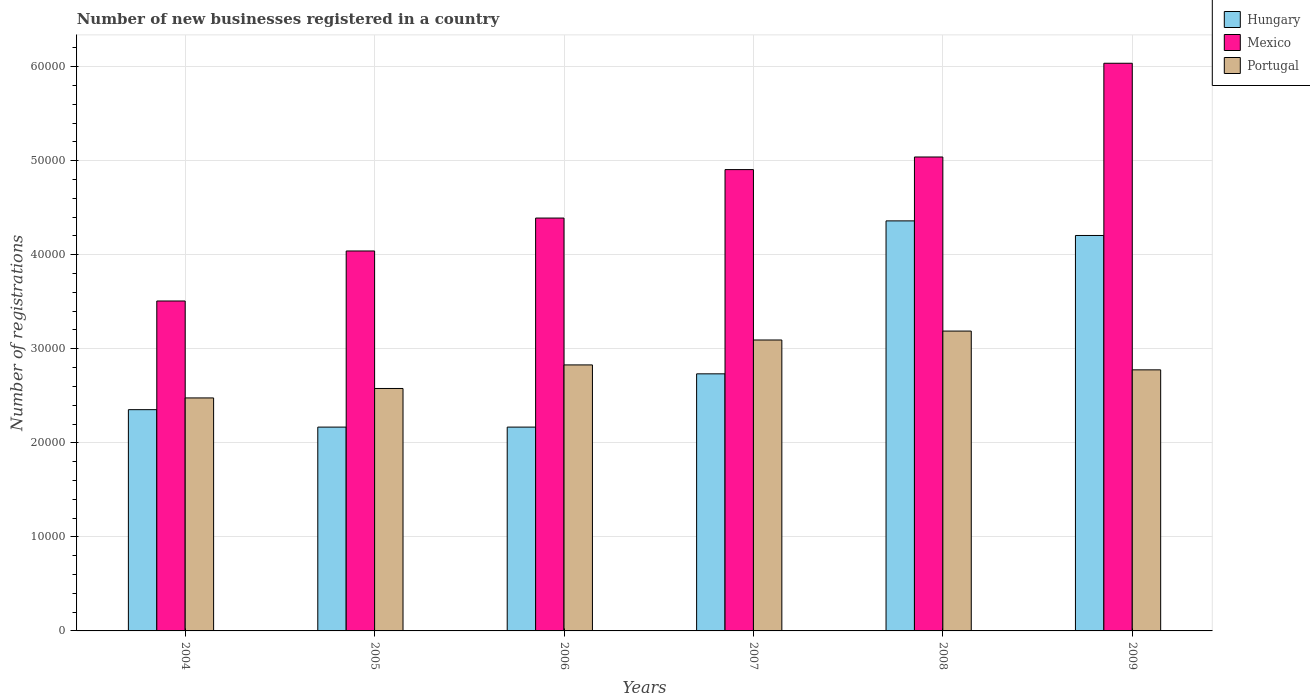How many different coloured bars are there?
Your answer should be very brief. 3. How many groups of bars are there?
Offer a very short reply. 6. How many bars are there on the 4th tick from the left?
Give a very brief answer. 3. How many bars are there on the 2nd tick from the right?
Ensure brevity in your answer.  3. What is the label of the 5th group of bars from the left?
Your answer should be compact. 2008. What is the number of new businesses registered in Mexico in 2005?
Your answer should be very brief. 4.04e+04. Across all years, what is the maximum number of new businesses registered in Mexico?
Your answer should be compact. 6.04e+04. Across all years, what is the minimum number of new businesses registered in Mexico?
Ensure brevity in your answer.  3.51e+04. In which year was the number of new businesses registered in Portugal maximum?
Keep it short and to the point. 2008. In which year was the number of new businesses registered in Hungary minimum?
Ensure brevity in your answer.  2005. What is the total number of new businesses registered in Portugal in the graph?
Offer a very short reply. 1.69e+05. What is the difference between the number of new businesses registered in Portugal in 2007 and that in 2009?
Provide a short and direct response. 3175. What is the difference between the number of new businesses registered in Portugal in 2007 and the number of new businesses registered in Hungary in 2005?
Your answer should be compact. 9262. What is the average number of new businesses registered in Portugal per year?
Give a very brief answer. 2.82e+04. In the year 2008, what is the difference between the number of new businesses registered in Portugal and number of new businesses registered in Hungary?
Provide a short and direct response. -1.17e+04. What is the ratio of the number of new businesses registered in Portugal in 2005 to that in 2007?
Your response must be concise. 0.83. What is the difference between the highest and the second highest number of new businesses registered in Hungary?
Provide a succinct answer. 1552. What is the difference between the highest and the lowest number of new businesses registered in Portugal?
Give a very brief answer. 7109. In how many years, is the number of new businesses registered in Mexico greater than the average number of new businesses registered in Mexico taken over all years?
Give a very brief answer. 3. What does the 2nd bar from the left in 2005 represents?
Your answer should be compact. Mexico. Is it the case that in every year, the sum of the number of new businesses registered in Mexico and number of new businesses registered in Hungary is greater than the number of new businesses registered in Portugal?
Keep it short and to the point. Yes. How many years are there in the graph?
Provide a succinct answer. 6. Are the values on the major ticks of Y-axis written in scientific E-notation?
Ensure brevity in your answer.  No. Where does the legend appear in the graph?
Keep it short and to the point. Top right. What is the title of the graph?
Offer a very short reply. Number of new businesses registered in a country. What is the label or title of the X-axis?
Make the answer very short. Years. What is the label or title of the Y-axis?
Make the answer very short. Number of registrations. What is the Number of registrations in Hungary in 2004?
Provide a succinct answer. 2.35e+04. What is the Number of registrations in Mexico in 2004?
Offer a terse response. 3.51e+04. What is the Number of registrations of Portugal in 2004?
Your answer should be very brief. 2.48e+04. What is the Number of registrations in Hungary in 2005?
Give a very brief answer. 2.17e+04. What is the Number of registrations of Mexico in 2005?
Keep it short and to the point. 4.04e+04. What is the Number of registrations in Portugal in 2005?
Ensure brevity in your answer.  2.58e+04. What is the Number of registrations in Hungary in 2006?
Provide a short and direct response. 2.17e+04. What is the Number of registrations of Mexico in 2006?
Offer a terse response. 4.39e+04. What is the Number of registrations of Portugal in 2006?
Your answer should be very brief. 2.83e+04. What is the Number of registrations in Hungary in 2007?
Offer a very short reply. 2.73e+04. What is the Number of registrations of Mexico in 2007?
Provide a succinct answer. 4.90e+04. What is the Number of registrations in Portugal in 2007?
Keep it short and to the point. 3.09e+04. What is the Number of registrations in Hungary in 2008?
Offer a very short reply. 4.36e+04. What is the Number of registrations of Mexico in 2008?
Your answer should be compact. 5.04e+04. What is the Number of registrations of Portugal in 2008?
Provide a succinct answer. 3.19e+04. What is the Number of registrations of Hungary in 2009?
Provide a short and direct response. 4.20e+04. What is the Number of registrations in Mexico in 2009?
Your answer should be compact. 6.04e+04. What is the Number of registrations of Portugal in 2009?
Offer a very short reply. 2.78e+04. Across all years, what is the maximum Number of registrations of Hungary?
Offer a terse response. 4.36e+04. Across all years, what is the maximum Number of registrations of Mexico?
Provide a short and direct response. 6.04e+04. Across all years, what is the maximum Number of registrations of Portugal?
Offer a terse response. 3.19e+04. Across all years, what is the minimum Number of registrations of Hungary?
Your answer should be very brief. 2.17e+04. Across all years, what is the minimum Number of registrations of Mexico?
Make the answer very short. 3.51e+04. Across all years, what is the minimum Number of registrations in Portugal?
Your answer should be very brief. 2.48e+04. What is the total Number of registrations of Hungary in the graph?
Offer a terse response. 1.80e+05. What is the total Number of registrations in Mexico in the graph?
Keep it short and to the point. 2.79e+05. What is the total Number of registrations in Portugal in the graph?
Keep it short and to the point. 1.69e+05. What is the difference between the Number of registrations of Hungary in 2004 and that in 2005?
Offer a very short reply. 1854. What is the difference between the Number of registrations of Mexico in 2004 and that in 2005?
Offer a terse response. -5317. What is the difference between the Number of registrations of Portugal in 2004 and that in 2005?
Offer a very short reply. -1005. What is the difference between the Number of registrations in Hungary in 2004 and that in 2006?
Provide a short and direct response. 1854. What is the difference between the Number of registrations in Mexico in 2004 and that in 2006?
Offer a terse response. -8818. What is the difference between the Number of registrations in Portugal in 2004 and that in 2006?
Your answer should be compact. -3510. What is the difference between the Number of registrations in Hungary in 2004 and that in 2007?
Provide a short and direct response. -3809. What is the difference between the Number of registrations of Mexico in 2004 and that in 2007?
Ensure brevity in your answer.  -1.40e+04. What is the difference between the Number of registrations of Portugal in 2004 and that in 2007?
Provide a short and direct response. -6160. What is the difference between the Number of registrations in Hungary in 2004 and that in 2008?
Offer a terse response. -2.01e+04. What is the difference between the Number of registrations of Mexico in 2004 and that in 2008?
Keep it short and to the point. -1.53e+04. What is the difference between the Number of registrations in Portugal in 2004 and that in 2008?
Provide a succinct answer. -7109. What is the difference between the Number of registrations of Hungary in 2004 and that in 2009?
Make the answer very short. -1.85e+04. What is the difference between the Number of registrations of Mexico in 2004 and that in 2009?
Provide a short and direct response. -2.53e+04. What is the difference between the Number of registrations of Portugal in 2004 and that in 2009?
Provide a succinct answer. -2985. What is the difference between the Number of registrations of Hungary in 2005 and that in 2006?
Provide a succinct answer. 0. What is the difference between the Number of registrations in Mexico in 2005 and that in 2006?
Provide a succinct answer. -3501. What is the difference between the Number of registrations of Portugal in 2005 and that in 2006?
Offer a terse response. -2505. What is the difference between the Number of registrations in Hungary in 2005 and that in 2007?
Provide a short and direct response. -5663. What is the difference between the Number of registrations of Mexico in 2005 and that in 2007?
Your answer should be very brief. -8652. What is the difference between the Number of registrations of Portugal in 2005 and that in 2007?
Give a very brief answer. -5155. What is the difference between the Number of registrations in Hungary in 2005 and that in 2008?
Your answer should be compact. -2.19e+04. What is the difference between the Number of registrations in Mexico in 2005 and that in 2008?
Give a very brief answer. -9994. What is the difference between the Number of registrations of Portugal in 2005 and that in 2008?
Keep it short and to the point. -6104. What is the difference between the Number of registrations in Hungary in 2005 and that in 2009?
Make the answer very short. -2.04e+04. What is the difference between the Number of registrations of Mexico in 2005 and that in 2009?
Your response must be concise. -2.00e+04. What is the difference between the Number of registrations of Portugal in 2005 and that in 2009?
Provide a succinct answer. -1980. What is the difference between the Number of registrations in Hungary in 2006 and that in 2007?
Your answer should be very brief. -5663. What is the difference between the Number of registrations of Mexico in 2006 and that in 2007?
Make the answer very short. -5151. What is the difference between the Number of registrations of Portugal in 2006 and that in 2007?
Your answer should be compact. -2650. What is the difference between the Number of registrations in Hungary in 2006 and that in 2008?
Ensure brevity in your answer.  -2.19e+04. What is the difference between the Number of registrations in Mexico in 2006 and that in 2008?
Provide a short and direct response. -6493. What is the difference between the Number of registrations in Portugal in 2006 and that in 2008?
Give a very brief answer. -3599. What is the difference between the Number of registrations of Hungary in 2006 and that in 2009?
Your answer should be very brief. -2.04e+04. What is the difference between the Number of registrations in Mexico in 2006 and that in 2009?
Provide a short and direct response. -1.65e+04. What is the difference between the Number of registrations of Portugal in 2006 and that in 2009?
Offer a terse response. 525. What is the difference between the Number of registrations in Hungary in 2007 and that in 2008?
Your response must be concise. -1.63e+04. What is the difference between the Number of registrations in Mexico in 2007 and that in 2008?
Your response must be concise. -1342. What is the difference between the Number of registrations of Portugal in 2007 and that in 2008?
Make the answer very short. -949. What is the difference between the Number of registrations of Hungary in 2007 and that in 2009?
Your answer should be compact. -1.47e+04. What is the difference between the Number of registrations of Mexico in 2007 and that in 2009?
Keep it short and to the point. -1.13e+04. What is the difference between the Number of registrations in Portugal in 2007 and that in 2009?
Make the answer very short. 3175. What is the difference between the Number of registrations of Hungary in 2008 and that in 2009?
Make the answer very short. 1552. What is the difference between the Number of registrations of Mexico in 2008 and that in 2009?
Ensure brevity in your answer.  -9966. What is the difference between the Number of registrations of Portugal in 2008 and that in 2009?
Your answer should be very brief. 4124. What is the difference between the Number of registrations in Hungary in 2004 and the Number of registrations in Mexico in 2005?
Offer a very short reply. -1.69e+04. What is the difference between the Number of registrations in Hungary in 2004 and the Number of registrations in Portugal in 2005?
Your answer should be compact. -2253. What is the difference between the Number of registrations in Mexico in 2004 and the Number of registrations in Portugal in 2005?
Offer a very short reply. 9302. What is the difference between the Number of registrations in Hungary in 2004 and the Number of registrations in Mexico in 2006?
Provide a succinct answer. -2.04e+04. What is the difference between the Number of registrations in Hungary in 2004 and the Number of registrations in Portugal in 2006?
Ensure brevity in your answer.  -4758. What is the difference between the Number of registrations in Mexico in 2004 and the Number of registrations in Portugal in 2006?
Provide a short and direct response. 6797. What is the difference between the Number of registrations in Hungary in 2004 and the Number of registrations in Mexico in 2007?
Ensure brevity in your answer.  -2.55e+04. What is the difference between the Number of registrations in Hungary in 2004 and the Number of registrations in Portugal in 2007?
Make the answer very short. -7408. What is the difference between the Number of registrations in Mexico in 2004 and the Number of registrations in Portugal in 2007?
Ensure brevity in your answer.  4147. What is the difference between the Number of registrations of Hungary in 2004 and the Number of registrations of Mexico in 2008?
Your answer should be compact. -2.69e+04. What is the difference between the Number of registrations of Hungary in 2004 and the Number of registrations of Portugal in 2008?
Your answer should be very brief. -8357. What is the difference between the Number of registrations of Mexico in 2004 and the Number of registrations of Portugal in 2008?
Ensure brevity in your answer.  3198. What is the difference between the Number of registrations of Hungary in 2004 and the Number of registrations of Mexico in 2009?
Offer a terse response. -3.68e+04. What is the difference between the Number of registrations in Hungary in 2004 and the Number of registrations in Portugal in 2009?
Your answer should be very brief. -4233. What is the difference between the Number of registrations of Mexico in 2004 and the Number of registrations of Portugal in 2009?
Your answer should be very brief. 7322. What is the difference between the Number of registrations of Hungary in 2005 and the Number of registrations of Mexico in 2006?
Give a very brief answer. -2.22e+04. What is the difference between the Number of registrations of Hungary in 2005 and the Number of registrations of Portugal in 2006?
Provide a short and direct response. -6612. What is the difference between the Number of registrations in Mexico in 2005 and the Number of registrations in Portugal in 2006?
Make the answer very short. 1.21e+04. What is the difference between the Number of registrations in Hungary in 2005 and the Number of registrations in Mexico in 2007?
Provide a short and direct response. -2.74e+04. What is the difference between the Number of registrations of Hungary in 2005 and the Number of registrations of Portugal in 2007?
Ensure brevity in your answer.  -9262. What is the difference between the Number of registrations of Mexico in 2005 and the Number of registrations of Portugal in 2007?
Make the answer very short. 9464. What is the difference between the Number of registrations of Hungary in 2005 and the Number of registrations of Mexico in 2008?
Keep it short and to the point. -2.87e+04. What is the difference between the Number of registrations in Hungary in 2005 and the Number of registrations in Portugal in 2008?
Your answer should be very brief. -1.02e+04. What is the difference between the Number of registrations in Mexico in 2005 and the Number of registrations in Portugal in 2008?
Keep it short and to the point. 8515. What is the difference between the Number of registrations of Hungary in 2005 and the Number of registrations of Mexico in 2009?
Your response must be concise. -3.87e+04. What is the difference between the Number of registrations in Hungary in 2005 and the Number of registrations in Portugal in 2009?
Your answer should be very brief. -6087. What is the difference between the Number of registrations in Mexico in 2005 and the Number of registrations in Portugal in 2009?
Offer a very short reply. 1.26e+04. What is the difference between the Number of registrations of Hungary in 2006 and the Number of registrations of Mexico in 2007?
Keep it short and to the point. -2.74e+04. What is the difference between the Number of registrations of Hungary in 2006 and the Number of registrations of Portugal in 2007?
Keep it short and to the point. -9262. What is the difference between the Number of registrations of Mexico in 2006 and the Number of registrations of Portugal in 2007?
Give a very brief answer. 1.30e+04. What is the difference between the Number of registrations in Hungary in 2006 and the Number of registrations in Mexico in 2008?
Keep it short and to the point. -2.87e+04. What is the difference between the Number of registrations in Hungary in 2006 and the Number of registrations in Portugal in 2008?
Your answer should be very brief. -1.02e+04. What is the difference between the Number of registrations in Mexico in 2006 and the Number of registrations in Portugal in 2008?
Your response must be concise. 1.20e+04. What is the difference between the Number of registrations in Hungary in 2006 and the Number of registrations in Mexico in 2009?
Your answer should be compact. -3.87e+04. What is the difference between the Number of registrations of Hungary in 2006 and the Number of registrations of Portugal in 2009?
Ensure brevity in your answer.  -6087. What is the difference between the Number of registrations in Mexico in 2006 and the Number of registrations in Portugal in 2009?
Your answer should be very brief. 1.61e+04. What is the difference between the Number of registrations in Hungary in 2007 and the Number of registrations in Mexico in 2008?
Offer a terse response. -2.31e+04. What is the difference between the Number of registrations in Hungary in 2007 and the Number of registrations in Portugal in 2008?
Provide a short and direct response. -4548. What is the difference between the Number of registrations in Mexico in 2007 and the Number of registrations in Portugal in 2008?
Your answer should be very brief. 1.72e+04. What is the difference between the Number of registrations in Hungary in 2007 and the Number of registrations in Mexico in 2009?
Keep it short and to the point. -3.30e+04. What is the difference between the Number of registrations in Hungary in 2007 and the Number of registrations in Portugal in 2009?
Ensure brevity in your answer.  -424. What is the difference between the Number of registrations in Mexico in 2007 and the Number of registrations in Portugal in 2009?
Keep it short and to the point. 2.13e+04. What is the difference between the Number of registrations in Hungary in 2008 and the Number of registrations in Mexico in 2009?
Your answer should be compact. -1.68e+04. What is the difference between the Number of registrations of Hungary in 2008 and the Number of registrations of Portugal in 2009?
Your response must be concise. 1.58e+04. What is the difference between the Number of registrations of Mexico in 2008 and the Number of registrations of Portugal in 2009?
Your answer should be compact. 2.26e+04. What is the average Number of registrations in Hungary per year?
Your response must be concise. 3.00e+04. What is the average Number of registrations of Mexico per year?
Make the answer very short. 4.65e+04. What is the average Number of registrations of Portugal per year?
Your answer should be compact. 2.82e+04. In the year 2004, what is the difference between the Number of registrations of Hungary and Number of registrations of Mexico?
Ensure brevity in your answer.  -1.16e+04. In the year 2004, what is the difference between the Number of registrations in Hungary and Number of registrations in Portugal?
Provide a short and direct response. -1248. In the year 2004, what is the difference between the Number of registrations in Mexico and Number of registrations in Portugal?
Offer a terse response. 1.03e+04. In the year 2005, what is the difference between the Number of registrations in Hungary and Number of registrations in Mexico?
Provide a short and direct response. -1.87e+04. In the year 2005, what is the difference between the Number of registrations of Hungary and Number of registrations of Portugal?
Your answer should be compact. -4107. In the year 2005, what is the difference between the Number of registrations of Mexico and Number of registrations of Portugal?
Your answer should be compact. 1.46e+04. In the year 2006, what is the difference between the Number of registrations in Hungary and Number of registrations in Mexico?
Provide a short and direct response. -2.22e+04. In the year 2006, what is the difference between the Number of registrations in Hungary and Number of registrations in Portugal?
Offer a very short reply. -6612. In the year 2006, what is the difference between the Number of registrations of Mexico and Number of registrations of Portugal?
Offer a terse response. 1.56e+04. In the year 2007, what is the difference between the Number of registrations in Hungary and Number of registrations in Mexico?
Keep it short and to the point. -2.17e+04. In the year 2007, what is the difference between the Number of registrations of Hungary and Number of registrations of Portugal?
Keep it short and to the point. -3599. In the year 2007, what is the difference between the Number of registrations of Mexico and Number of registrations of Portugal?
Offer a very short reply. 1.81e+04. In the year 2008, what is the difference between the Number of registrations of Hungary and Number of registrations of Mexico?
Your answer should be compact. -6794. In the year 2008, what is the difference between the Number of registrations of Hungary and Number of registrations of Portugal?
Provide a succinct answer. 1.17e+04. In the year 2008, what is the difference between the Number of registrations of Mexico and Number of registrations of Portugal?
Keep it short and to the point. 1.85e+04. In the year 2009, what is the difference between the Number of registrations in Hungary and Number of registrations in Mexico?
Your answer should be very brief. -1.83e+04. In the year 2009, what is the difference between the Number of registrations in Hungary and Number of registrations in Portugal?
Your answer should be very brief. 1.43e+04. In the year 2009, what is the difference between the Number of registrations in Mexico and Number of registrations in Portugal?
Make the answer very short. 3.26e+04. What is the ratio of the Number of registrations of Hungary in 2004 to that in 2005?
Ensure brevity in your answer.  1.09. What is the ratio of the Number of registrations in Mexico in 2004 to that in 2005?
Make the answer very short. 0.87. What is the ratio of the Number of registrations in Portugal in 2004 to that in 2005?
Offer a very short reply. 0.96. What is the ratio of the Number of registrations of Hungary in 2004 to that in 2006?
Your answer should be compact. 1.09. What is the ratio of the Number of registrations in Mexico in 2004 to that in 2006?
Provide a short and direct response. 0.8. What is the ratio of the Number of registrations in Portugal in 2004 to that in 2006?
Your answer should be compact. 0.88. What is the ratio of the Number of registrations in Hungary in 2004 to that in 2007?
Ensure brevity in your answer.  0.86. What is the ratio of the Number of registrations in Mexico in 2004 to that in 2007?
Your response must be concise. 0.72. What is the ratio of the Number of registrations in Portugal in 2004 to that in 2007?
Make the answer very short. 0.8. What is the ratio of the Number of registrations of Hungary in 2004 to that in 2008?
Provide a short and direct response. 0.54. What is the ratio of the Number of registrations in Mexico in 2004 to that in 2008?
Make the answer very short. 0.7. What is the ratio of the Number of registrations in Portugal in 2004 to that in 2008?
Give a very brief answer. 0.78. What is the ratio of the Number of registrations of Hungary in 2004 to that in 2009?
Your response must be concise. 0.56. What is the ratio of the Number of registrations of Mexico in 2004 to that in 2009?
Provide a short and direct response. 0.58. What is the ratio of the Number of registrations in Portugal in 2004 to that in 2009?
Offer a terse response. 0.89. What is the ratio of the Number of registrations in Mexico in 2005 to that in 2006?
Provide a short and direct response. 0.92. What is the ratio of the Number of registrations of Portugal in 2005 to that in 2006?
Keep it short and to the point. 0.91. What is the ratio of the Number of registrations of Hungary in 2005 to that in 2007?
Make the answer very short. 0.79. What is the ratio of the Number of registrations of Mexico in 2005 to that in 2007?
Keep it short and to the point. 0.82. What is the ratio of the Number of registrations in Portugal in 2005 to that in 2007?
Offer a very short reply. 0.83. What is the ratio of the Number of registrations in Hungary in 2005 to that in 2008?
Your response must be concise. 0.5. What is the ratio of the Number of registrations in Mexico in 2005 to that in 2008?
Offer a terse response. 0.8. What is the ratio of the Number of registrations of Portugal in 2005 to that in 2008?
Offer a terse response. 0.81. What is the ratio of the Number of registrations of Hungary in 2005 to that in 2009?
Provide a short and direct response. 0.52. What is the ratio of the Number of registrations of Mexico in 2005 to that in 2009?
Your answer should be very brief. 0.67. What is the ratio of the Number of registrations of Portugal in 2005 to that in 2009?
Provide a succinct answer. 0.93. What is the ratio of the Number of registrations in Hungary in 2006 to that in 2007?
Make the answer very short. 0.79. What is the ratio of the Number of registrations in Mexico in 2006 to that in 2007?
Make the answer very short. 0.9. What is the ratio of the Number of registrations of Portugal in 2006 to that in 2007?
Keep it short and to the point. 0.91. What is the ratio of the Number of registrations of Hungary in 2006 to that in 2008?
Give a very brief answer. 0.5. What is the ratio of the Number of registrations in Mexico in 2006 to that in 2008?
Offer a terse response. 0.87. What is the ratio of the Number of registrations in Portugal in 2006 to that in 2008?
Your response must be concise. 0.89. What is the ratio of the Number of registrations of Hungary in 2006 to that in 2009?
Offer a very short reply. 0.52. What is the ratio of the Number of registrations in Mexico in 2006 to that in 2009?
Keep it short and to the point. 0.73. What is the ratio of the Number of registrations of Portugal in 2006 to that in 2009?
Provide a succinct answer. 1.02. What is the ratio of the Number of registrations in Hungary in 2007 to that in 2008?
Offer a very short reply. 0.63. What is the ratio of the Number of registrations of Mexico in 2007 to that in 2008?
Provide a succinct answer. 0.97. What is the ratio of the Number of registrations of Portugal in 2007 to that in 2008?
Ensure brevity in your answer.  0.97. What is the ratio of the Number of registrations of Hungary in 2007 to that in 2009?
Your answer should be very brief. 0.65. What is the ratio of the Number of registrations in Mexico in 2007 to that in 2009?
Your response must be concise. 0.81. What is the ratio of the Number of registrations of Portugal in 2007 to that in 2009?
Keep it short and to the point. 1.11. What is the ratio of the Number of registrations of Hungary in 2008 to that in 2009?
Give a very brief answer. 1.04. What is the ratio of the Number of registrations of Mexico in 2008 to that in 2009?
Give a very brief answer. 0.83. What is the ratio of the Number of registrations of Portugal in 2008 to that in 2009?
Your answer should be compact. 1.15. What is the difference between the highest and the second highest Number of registrations of Hungary?
Make the answer very short. 1552. What is the difference between the highest and the second highest Number of registrations of Mexico?
Provide a succinct answer. 9966. What is the difference between the highest and the second highest Number of registrations of Portugal?
Give a very brief answer. 949. What is the difference between the highest and the lowest Number of registrations of Hungary?
Ensure brevity in your answer.  2.19e+04. What is the difference between the highest and the lowest Number of registrations of Mexico?
Make the answer very short. 2.53e+04. What is the difference between the highest and the lowest Number of registrations in Portugal?
Keep it short and to the point. 7109. 